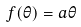<formula> <loc_0><loc_0><loc_500><loc_500>f ( \theta ) = a \theta</formula> 